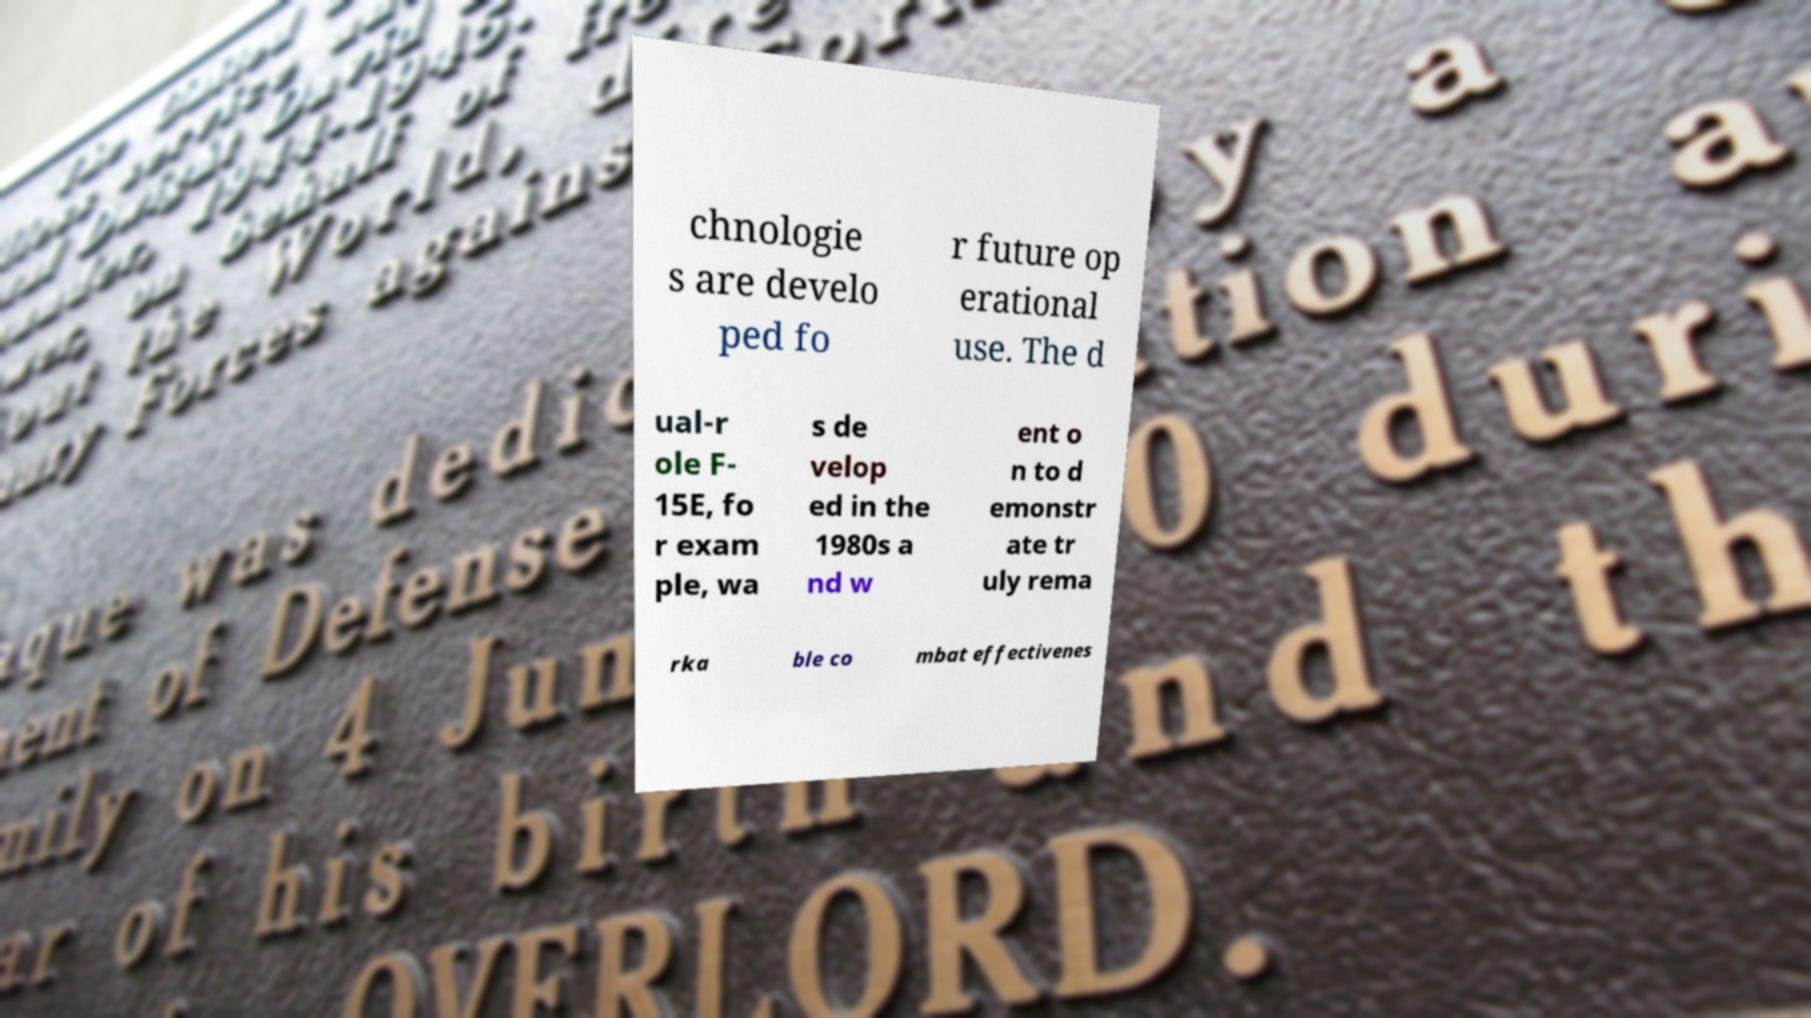Please identify and transcribe the text found in this image. chnologie s are develo ped fo r future op erational use. The d ual-r ole F- 15E, fo r exam ple, wa s de velop ed in the 1980s a nd w ent o n to d emonstr ate tr uly rema rka ble co mbat effectivenes 